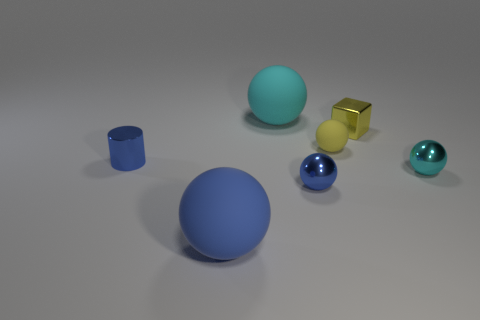Subtract all yellow balls. How many balls are left? 4 Subtract all small cyan balls. How many balls are left? 4 Add 3 large brown matte balls. How many objects exist? 10 Subtract all cyan spheres. Subtract all purple cubes. How many spheres are left? 3 Subtract all cylinders. How many objects are left? 6 Add 5 yellow shiny cubes. How many yellow shiny cubes exist? 6 Subtract 2 blue spheres. How many objects are left? 5 Subtract all big blue spheres. Subtract all cyan metallic spheres. How many objects are left? 5 Add 4 tiny metal cylinders. How many tiny metal cylinders are left? 5 